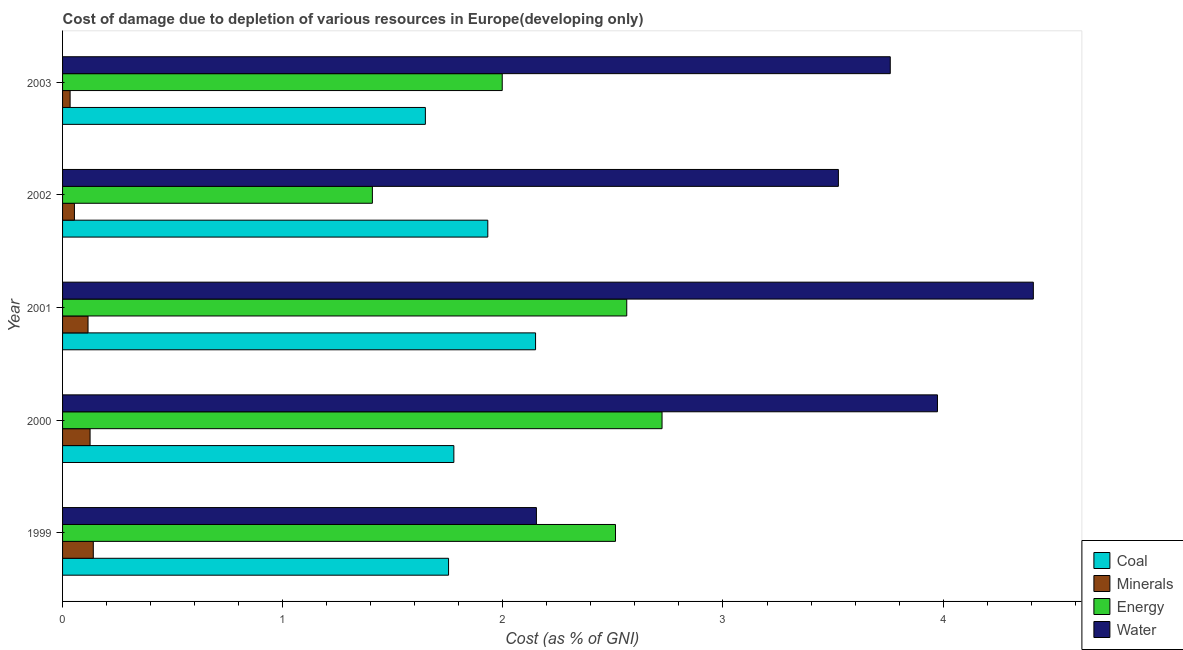Are the number of bars per tick equal to the number of legend labels?
Ensure brevity in your answer.  Yes. Are the number of bars on each tick of the Y-axis equal?
Your answer should be compact. Yes. How many bars are there on the 1st tick from the top?
Your answer should be very brief. 4. How many bars are there on the 3rd tick from the bottom?
Make the answer very short. 4. What is the label of the 2nd group of bars from the top?
Your response must be concise. 2002. In how many cases, is the number of bars for a given year not equal to the number of legend labels?
Offer a terse response. 0. What is the cost of damage due to depletion of water in 2001?
Offer a terse response. 4.41. Across all years, what is the maximum cost of damage due to depletion of minerals?
Offer a terse response. 0.14. Across all years, what is the minimum cost of damage due to depletion of energy?
Provide a succinct answer. 1.41. What is the total cost of damage due to depletion of coal in the graph?
Offer a very short reply. 9.26. What is the difference between the cost of damage due to depletion of water in 2001 and that in 2002?
Provide a succinct answer. 0.89. What is the difference between the cost of damage due to depletion of energy in 2002 and the cost of damage due to depletion of minerals in 1999?
Keep it short and to the point. 1.27. What is the average cost of damage due to depletion of energy per year?
Ensure brevity in your answer.  2.24. In the year 2001, what is the difference between the cost of damage due to depletion of energy and cost of damage due to depletion of coal?
Ensure brevity in your answer.  0.41. What is the ratio of the cost of damage due to depletion of minerals in 2000 to that in 2003?
Provide a succinct answer. 3.65. Is the difference between the cost of damage due to depletion of minerals in 2000 and 2001 greater than the difference between the cost of damage due to depletion of energy in 2000 and 2001?
Provide a succinct answer. No. What is the difference between the highest and the second highest cost of damage due to depletion of coal?
Make the answer very short. 0.22. What is the difference between the highest and the lowest cost of damage due to depletion of energy?
Ensure brevity in your answer.  1.32. Is the sum of the cost of damage due to depletion of energy in 1999 and 2001 greater than the maximum cost of damage due to depletion of water across all years?
Keep it short and to the point. Yes. Is it the case that in every year, the sum of the cost of damage due to depletion of coal and cost of damage due to depletion of energy is greater than the sum of cost of damage due to depletion of water and cost of damage due to depletion of minerals?
Offer a terse response. No. What does the 4th bar from the top in 2002 represents?
Give a very brief answer. Coal. What does the 2nd bar from the bottom in 2001 represents?
Your response must be concise. Minerals. Is it the case that in every year, the sum of the cost of damage due to depletion of coal and cost of damage due to depletion of minerals is greater than the cost of damage due to depletion of energy?
Ensure brevity in your answer.  No. How many bars are there?
Provide a succinct answer. 20. Are all the bars in the graph horizontal?
Make the answer very short. Yes. Does the graph contain grids?
Provide a short and direct response. No. How many legend labels are there?
Make the answer very short. 4. How are the legend labels stacked?
Make the answer very short. Vertical. What is the title of the graph?
Provide a succinct answer. Cost of damage due to depletion of various resources in Europe(developing only) . Does "Salary of employees" appear as one of the legend labels in the graph?
Your answer should be very brief. No. What is the label or title of the X-axis?
Give a very brief answer. Cost (as % of GNI). What is the label or title of the Y-axis?
Your response must be concise. Year. What is the Cost (as % of GNI) of Coal in 1999?
Provide a succinct answer. 1.75. What is the Cost (as % of GNI) in Minerals in 1999?
Your answer should be very brief. 0.14. What is the Cost (as % of GNI) in Energy in 1999?
Make the answer very short. 2.51. What is the Cost (as % of GNI) in Water in 1999?
Provide a succinct answer. 2.15. What is the Cost (as % of GNI) in Coal in 2000?
Provide a succinct answer. 1.78. What is the Cost (as % of GNI) of Minerals in 2000?
Offer a terse response. 0.12. What is the Cost (as % of GNI) in Energy in 2000?
Give a very brief answer. 2.72. What is the Cost (as % of GNI) in Water in 2000?
Your response must be concise. 3.97. What is the Cost (as % of GNI) in Coal in 2001?
Give a very brief answer. 2.15. What is the Cost (as % of GNI) in Minerals in 2001?
Provide a succinct answer. 0.12. What is the Cost (as % of GNI) of Energy in 2001?
Offer a terse response. 2.56. What is the Cost (as % of GNI) in Water in 2001?
Provide a short and direct response. 4.41. What is the Cost (as % of GNI) of Coal in 2002?
Give a very brief answer. 1.93. What is the Cost (as % of GNI) of Minerals in 2002?
Your answer should be very brief. 0.05. What is the Cost (as % of GNI) in Energy in 2002?
Keep it short and to the point. 1.41. What is the Cost (as % of GNI) in Water in 2002?
Your answer should be very brief. 3.52. What is the Cost (as % of GNI) of Coal in 2003?
Offer a very short reply. 1.65. What is the Cost (as % of GNI) of Minerals in 2003?
Offer a very short reply. 0.03. What is the Cost (as % of GNI) in Energy in 2003?
Provide a short and direct response. 2. What is the Cost (as % of GNI) of Water in 2003?
Keep it short and to the point. 3.76. Across all years, what is the maximum Cost (as % of GNI) in Coal?
Your answer should be very brief. 2.15. Across all years, what is the maximum Cost (as % of GNI) in Minerals?
Provide a succinct answer. 0.14. Across all years, what is the maximum Cost (as % of GNI) in Energy?
Give a very brief answer. 2.72. Across all years, what is the maximum Cost (as % of GNI) of Water?
Provide a short and direct response. 4.41. Across all years, what is the minimum Cost (as % of GNI) of Coal?
Your answer should be compact. 1.65. Across all years, what is the minimum Cost (as % of GNI) of Minerals?
Provide a succinct answer. 0.03. Across all years, what is the minimum Cost (as % of GNI) of Energy?
Ensure brevity in your answer.  1.41. Across all years, what is the minimum Cost (as % of GNI) in Water?
Offer a terse response. 2.15. What is the total Cost (as % of GNI) in Coal in the graph?
Offer a very short reply. 9.26. What is the total Cost (as % of GNI) of Minerals in the graph?
Make the answer very short. 0.47. What is the total Cost (as % of GNI) of Energy in the graph?
Keep it short and to the point. 11.2. What is the total Cost (as % of GNI) in Water in the graph?
Make the answer very short. 17.82. What is the difference between the Cost (as % of GNI) in Coal in 1999 and that in 2000?
Offer a very short reply. -0.02. What is the difference between the Cost (as % of GNI) of Minerals in 1999 and that in 2000?
Your response must be concise. 0.01. What is the difference between the Cost (as % of GNI) of Energy in 1999 and that in 2000?
Give a very brief answer. -0.21. What is the difference between the Cost (as % of GNI) in Water in 1999 and that in 2000?
Provide a succinct answer. -1.82. What is the difference between the Cost (as % of GNI) in Coal in 1999 and that in 2001?
Provide a succinct answer. -0.4. What is the difference between the Cost (as % of GNI) of Minerals in 1999 and that in 2001?
Offer a very short reply. 0.02. What is the difference between the Cost (as % of GNI) in Energy in 1999 and that in 2001?
Ensure brevity in your answer.  -0.05. What is the difference between the Cost (as % of GNI) in Water in 1999 and that in 2001?
Offer a terse response. -2.26. What is the difference between the Cost (as % of GNI) of Coal in 1999 and that in 2002?
Your response must be concise. -0.18. What is the difference between the Cost (as % of GNI) of Minerals in 1999 and that in 2002?
Provide a short and direct response. 0.09. What is the difference between the Cost (as % of GNI) of Energy in 1999 and that in 2002?
Give a very brief answer. 1.1. What is the difference between the Cost (as % of GNI) of Water in 1999 and that in 2002?
Offer a very short reply. -1.37. What is the difference between the Cost (as % of GNI) of Coal in 1999 and that in 2003?
Your answer should be very brief. 0.11. What is the difference between the Cost (as % of GNI) of Minerals in 1999 and that in 2003?
Ensure brevity in your answer.  0.11. What is the difference between the Cost (as % of GNI) in Energy in 1999 and that in 2003?
Provide a short and direct response. 0.51. What is the difference between the Cost (as % of GNI) in Water in 1999 and that in 2003?
Give a very brief answer. -1.61. What is the difference between the Cost (as % of GNI) of Coal in 2000 and that in 2001?
Offer a terse response. -0.37. What is the difference between the Cost (as % of GNI) of Minerals in 2000 and that in 2001?
Provide a short and direct response. 0.01. What is the difference between the Cost (as % of GNI) of Energy in 2000 and that in 2001?
Offer a very short reply. 0.16. What is the difference between the Cost (as % of GNI) in Water in 2000 and that in 2001?
Provide a short and direct response. -0.44. What is the difference between the Cost (as % of GNI) in Coal in 2000 and that in 2002?
Ensure brevity in your answer.  -0.15. What is the difference between the Cost (as % of GNI) in Minerals in 2000 and that in 2002?
Give a very brief answer. 0.07. What is the difference between the Cost (as % of GNI) of Energy in 2000 and that in 2002?
Offer a terse response. 1.32. What is the difference between the Cost (as % of GNI) of Water in 2000 and that in 2002?
Keep it short and to the point. 0.45. What is the difference between the Cost (as % of GNI) in Coal in 2000 and that in 2003?
Your answer should be compact. 0.13. What is the difference between the Cost (as % of GNI) of Minerals in 2000 and that in 2003?
Give a very brief answer. 0.09. What is the difference between the Cost (as % of GNI) in Energy in 2000 and that in 2003?
Make the answer very short. 0.73. What is the difference between the Cost (as % of GNI) in Water in 2000 and that in 2003?
Ensure brevity in your answer.  0.21. What is the difference between the Cost (as % of GNI) in Coal in 2001 and that in 2002?
Keep it short and to the point. 0.22. What is the difference between the Cost (as % of GNI) in Minerals in 2001 and that in 2002?
Keep it short and to the point. 0.06. What is the difference between the Cost (as % of GNI) of Energy in 2001 and that in 2002?
Provide a succinct answer. 1.16. What is the difference between the Cost (as % of GNI) in Water in 2001 and that in 2002?
Your response must be concise. 0.89. What is the difference between the Cost (as % of GNI) in Coal in 2001 and that in 2003?
Your answer should be compact. 0.5. What is the difference between the Cost (as % of GNI) of Minerals in 2001 and that in 2003?
Your answer should be very brief. 0.08. What is the difference between the Cost (as % of GNI) of Energy in 2001 and that in 2003?
Provide a succinct answer. 0.57. What is the difference between the Cost (as % of GNI) of Water in 2001 and that in 2003?
Provide a succinct answer. 0.65. What is the difference between the Cost (as % of GNI) in Coal in 2002 and that in 2003?
Give a very brief answer. 0.28. What is the difference between the Cost (as % of GNI) of Minerals in 2002 and that in 2003?
Ensure brevity in your answer.  0.02. What is the difference between the Cost (as % of GNI) of Energy in 2002 and that in 2003?
Offer a terse response. -0.59. What is the difference between the Cost (as % of GNI) in Water in 2002 and that in 2003?
Your answer should be very brief. -0.24. What is the difference between the Cost (as % of GNI) of Coal in 1999 and the Cost (as % of GNI) of Minerals in 2000?
Your response must be concise. 1.63. What is the difference between the Cost (as % of GNI) of Coal in 1999 and the Cost (as % of GNI) of Energy in 2000?
Provide a short and direct response. -0.97. What is the difference between the Cost (as % of GNI) in Coal in 1999 and the Cost (as % of GNI) in Water in 2000?
Your answer should be very brief. -2.22. What is the difference between the Cost (as % of GNI) in Minerals in 1999 and the Cost (as % of GNI) in Energy in 2000?
Keep it short and to the point. -2.58. What is the difference between the Cost (as % of GNI) of Minerals in 1999 and the Cost (as % of GNI) of Water in 2000?
Your answer should be compact. -3.83. What is the difference between the Cost (as % of GNI) in Energy in 1999 and the Cost (as % of GNI) in Water in 2000?
Give a very brief answer. -1.46. What is the difference between the Cost (as % of GNI) in Coal in 1999 and the Cost (as % of GNI) in Minerals in 2001?
Your answer should be compact. 1.64. What is the difference between the Cost (as % of GNI) in Coal in 1999 and the Cost (as % of GNI) in Energy in 2001?
Keep it short and to the point. -0.81. What is the difference between the Cost (as % of GNI) in Coal in 1999 and the Cost (as % of GNI) in Water in 2001?
Ensure brevity in your answer.  -2.66. What is the difference between the Cost (as % of GNI) of Minerals in 1999 and the Cost (as % of GNI) of Energy in 2001?
Provide a succinct answer. -2.42. What is the difference between the Cost (as % of GNI) in Minerals in 1999 and the Cost (as % of GNI) in Water in 2001?
Provide a short and direct response. -4.27. What is the difference between the Cost (as % of GNI) in Energy in 1999 and the Cost (as % of GNI) in Water in 2001?
Provide a succinct answer. -1.9. What is the difference between the Cost (as % of GNI) in Coal in 1999 and the Cost (as % of GNI) in Minerals in 2002?
Your answer should be compact. 1.7. What is the difference between the Cost (as % of GNI) of Coal in 1999 and the Cost (as % of GNI) of Energy in 2002?
Give a very brief answer. 0.35. What is the difference between the Cost (as % of GNI) in Coal in 1999 and the Cost (as % of GNI) in Water in 2002?
Your answer should be compact. -1.77. What is the difference between the Cost (as % of GNI) in Minerals in 1999 and the Cost (as % of GNI) in Energy in 2002?
Offer a terse response. -1.27. What is the difference between the Cost (as % of GNI) in Minerals in 1999 and the Cost (as % of GNI) in Water in 2002?
Keep it short and to the point. -3.38. What is the difference between the Cost (as % of GNI) of Energy in 1999 and the Cost (as % of GNI) of Water in 2002?
Your response must be concise. -1.01. What is the difference between the Cost (as % of GNI) in Coal in 1999 and the Cost (as % of GNI) in Minerals in 2003?
Make the answer very short. 1.72. What is the difference between the Cost (as % of GNI) of Coal in 1999 and the Cost (as % of GNI) of Energy in 2003?
Your answer should be compact. -0.24. What is the difference between the Cost (as % of GNI) of Coal in 1999 and the Cost (as % of GNI) of Water in 2003?
Provide a succinct answer. -2.01. What is the difference between the Cost (as % of GNI) in Minerals in 1999 and the Cost (as % of GNI) in Energy in 2003?
Your answer should be compact. -1.86. What is the difference between the Cost (as % of GNI) in Minerals in 1999 and the Cost (as % of GNI) in Water in 2003?
Offer a very short reply. -3.62. What is the difference between the Cost (as % of GNI) of Energy in 1999 and the Cost (as % of GNI) of Water in 2003?
Ensure brevity in your answer.  -1.25. What is the difference between the Cost (as % of GNI) in Coal in 2000 and the Cost (as % of GNI) in Minerals in 2001?
Provide a succinct answer. 1.66. What is the difference between the Cost (as % of GNI) of Coal in 2000 and the Cost (as % of GNI) of Energy in 2001?
Offer a very short reply. -0.79. What is the difference between the Cost (as % of GNI) in Coal in 2000 and the Cost (as % of GNI) in Water in 2001?
Make the answer very short. -2.63. What is the difference between the Cost (as % of GNI) of Minerals in 2000 and the Cost (as % of GNI) of Energy in 2001?
Provide a short and direct response. -2.44. What is the difference between the Cost (as % of GNI) of Minerals in 2000 and the Cost (as % of GNI) of Water in 2001?
Give a very brief answer. -4.28. What is the difference between the Cost (as % of GNI) of Energy in 2000 and the Cost (as % of GNI) of Water in 2001?
Offer a terse response. -1.69. What is the difference between the Cost (as % of GNI) of Coal in 2000 and the Cost (as % of GNI) of Minerals in 2002?
Ensure brevity in your answer.  1.72. What is the difference between the Cost (as % of GNI) of Coal in 2000 and the Cost (as % of GNI) of Energy in 2002?
Keep it short and to the point. 0.37. What is the difference between the Cost (as % of GNI) of Coal in 2000 and the Cost (as % of GNI) of Water in 2002?
Offer a terse response. -1.75. What is the difference between the Cost (as % of GNI) in Minerals in 2000 and the Cost (as % of GNI) in Energy in 2002?
Give a very brief answer. -1.28. What is the difference between the Cost (as % of GNI) of Minerals in 2000 and the Cost (as % of GNI) of Water in 2002?
Offer a very short reply. -3.4. What is the difference between the Cost (as % of GNI) of Energy in 2000 and the Cost (as % of GNI) of Water in 2002?
Your answer should be compact. -0.8. What is the difference between the Cost (as % of GNI) in Coal in 2000 and the Cost (as % of GNI) in Minerals in 2003?
Offer a terse response. 1.74. What is the difference between the Cost (as % of GNI) of Coal in 2000 and the Cost (as % of GNI) of Energy in 2003?
Ensure brevity in your answer.  -0.22. What is the difference between the Cost (as % of GNI) of Coal in 2000 and the Cost (as % of GNI) of Water in 2003?
Make the answer very short. -1.98. What is the difference between the Cost (as % of GNI) in Minerals in 2000 and the Cost (as % of GNI) in Energy in 2003?
Make the answer very short. -1.87. What is the difference between the Cost (as % of GNI) of Minerals in 2000 and the Cost (as % of GNI) of Water in 2003?
Offer a very short reply. -3.63. What is the difference between the Cost (as % of GNI) in Energy in 2000 and the Cost (as % of GNI) in Water in 2003?
Your answer should be very brief. -1.04. What is the difference between the Cost (as % of GNI) in Coal in 2001 and the Cost (as % of GNI) in Minerals in 2002?
Your response must be concise. 2.09. What is the difference between the Cost (as % of GNI) in Coal in 2001 and the Cost (as % of GNI) in Energy in 2002?
Provide a succinct answer. 0.74. What is the difference between the Cost (as % of GNI) of Coal in 2001 and the Cost (as % of GNI) of Water in 2002?
Ensure brevity in your answer.  -1.38. What is the difference between the Cost (as % of GNI) of Minerals in 2001 and the Cost (as % of GNI) of Energy in 2002?
Offer a terse response. -1.29. What is the difference between the Cost (as % of GNI) of Minerals in 2001 and the Cost (as % of GNI) of Water in 2002?
Your response must be concise. -3.41. What is the difference between the Cost (as % of GNI) of Energy in 2001 and the Cost (as % of GNI) of Water in 2002?
Offer a very short reply. -0.96. What is the difference between the Cost (as % of GNI) of Coal in 2001 and the Cost (as % of GNI) of Minerals in 2003?
Ensure brevity in your answer.  2.11. What is the difference between the Cost (as % of GNI) of Coal in 2001 and the Cost (as % of GNI) of Energy in 2003?
Make the answer very short. 0.15. What is the difference between the Cost (as % of GNI) of Coal in 2001 and the Cost (as % of GNI) of Water in 2003?
Keep it short and to the point. -1.61. What is the difference between the Cost (as % of GNI) of Minerals in 2001 and the Cost (as % of GNI) of Energy in 2003?
Provide a succinct answer. -1.88. What is the difference between the Cost (as % of GNI) in Minerals in 2001 and the Cost (as % of GNI) in Water in 2003?
Offer a very short reply. -3.64. What is the difference between the Cost (as % of GNI) of Energy in 2001 and the Cost (as % of GNI) of Water in 2003?
Your answer should be very brief. -1.2. What is the difference between the Cost (as % of GNI) in Coal in 2002 and the Cost (as % of GNI) in Minerals in 2003?
Your answer should be very brief. 1.9. What is the difference between the Cost (as % of GNI) in Coal in 2002 and the Cost (as % of GNI) in Energy in 2003?
Your answer should be compact. -0.07. What is the difference between the Cost (as % of GNI) in Coal in 2002 and the Cost (as % of GNI) in Water in 2003?
Your answer should be very brief. -1.83. What is the difference between the Cost (as % of GNI) of Minerals in 2002 and the Cost (as % of GNI) of Energy in 2003?
Your response must be concise. -1.94. What is the difference between the Cost (as % of GNI) in Minerals in 2002 and the Cost (as % of GNI) in Water in 2003?
Give a very brief answer. -3.71. What is the difference between the Cost (as % of GNI) in Energy in 2002 and the Cost (as % of GNI) in Water in 2003?
Offer a terse response. -2.35. What is the average Cost (as % of GNI) of Coal per year?
Provide a short and direct response. 1.85. What is the average Cost (as % of GNI) of Minerals per year?
Make the answer very short. 0.09. What is the average Cost (as % of GNI) of Energy per year?
Give a very brief answer. 2.24. What is the average Cost (as % of GNI) of Water per year?
Provide a short and direct response. 3.56. In the year 1999, what is the difference between the Cost (as % of GNI) in Coal and Cost (as % of GNI) in Minerals?
Your answer should be very brief. 1.61. In the year 1999, what is the difference between the Cost (as % of GNI) in Coal and Cost (as % of GNI) in Energy?
Your answer should be compact. -0.76. In the year 1999, what is the difference between the Cost (as % of GNI) in Coal and Cost (as % of GNI) in Water?
Make the answer very short. -0.4. In the year 1999, what is the difference between the Cost (as % of GNI) of Minerals and Cost (as % of GNI) of Energy?
Make the answer very short. -2.37. In the year 1999, what is the difference between the Cost (as % of GNI) in Minerals and Cost (as % of GNI) in Water?
Keep it short and to the point. -2.01. In the year 1999, what is the difference between the Cost (as % of GNI) of Energy and Cost (as % of GNI) of Water?
Give a very brief answer. 0.36. In the year 2000, what is the difference between the Cost (as % of GNI) of Coal and Cost (as % of GNI) of Minerals?
Offer a very short reply. 1.65. In the year 2000, what is the difference between the Cost (as % of GNI) of Coal and Cost (as % of GNI) of Energy?
Ensure brevity in your answer.  -0.95. In the year 2000, what is the difference between the Cost (as % of GNI) of Coal and Cost (as % of GNI) of Water?
Ensure brevity in your answer.  -2.2. In the year 2000, what is the difference between the Cost (as % of GNI) of Minerals and Cost (as % of GNI) of Energy?
Ensure brevity in your answer.  -2.6. In the year 2000, what is the difference between the Cost (as % of GNI) of Minerals and Cost (as % of GNI) of Water?
Give a very brief answer. -3.85. In the year 2000, what is the difference between the Cost (as % of GNI) of Energy and Cost (as % of GNI) of Water?
Ensure brevity in your answer.  -1.25. In the year 2001, what is the difference between the Cost (as % of GNI) of Coal and Cost (as % of GNI) of Minerals?
Ensure brevity in your answer.  2.03. In the year 2001, what is the difference between the Cost (as % of GNI) of Coal and Cost (as % of GNI) of Energy?
Keep it short and to the point. -0.41. In the year 2001, what is the difference between the Cost (as % of GNI) of Coal and Cost (as % of GNI) of Water?
Offer a terse response. -2.26. In the year 2001, what is the difference between the Cost (as % of GNI) of Minerals and Cost (as % of GNI) of Energy?
Provide a succinct answer. -2.45. In the year 2001, what is the difference between the Cost (as % of GNI) of Minerals and Cost (as % of GNI) of Water?
Provide a short and direct response. -4.29. In the year 2001, what is the difference between the Cost (as % of GNI) in Energy and Cost (as % of GNI) in Water?
Make the answer very short. -1.85. In the year 2002, what is the difference between the Cost (as % of GNI) in Coal and Cost (as % of GNI) in Minerals?
Give a very brief answer. 1.88. In the year 2002, what is the difference between the Cost (as % of GNI) in Coal and Cost (as % of GNI) in Energy?
Offer a terse response. 0.52. In the year 2002, what is the difference between the Cost (as % of GNI) in Coal and Cost (as % of GNI) in Water?
Make the answer very short. -1.59. In the year 2002, what is the difference between the Cost (as % of GNI) in Minerals and Cost (as % of GNI) in Energy?
Your answer should be very brief. -1.35. In the year 2002, what is the difference between the Cost (as % of GNI) in Minerals and Cost (as % of GNI) in Water?
Make the answer very short. -3.47. In the year 2002, what is the difference between the Cost (as % of GNI) in Energy and Cost (as % of GNI) in Water?
Your response must be concise. -2.12. In the year 2003, what is the difference between the Cost (as % of GNI) of Coal and Cost (as % of GNI) of Minerals?
Your response must be concise. 1.61. In the year 2003, what is the difference between the Cost (as % of GNI) in Coal and Cost (as % of GNI) in Energy?
Your answer should be very brief. -0.35. In the year 2003, what is the difference between the Cost (as % of GNI) of Coal and Cost (as % of GNI) of Water?
Your response must be concise. -2.11. In the year 2003, what is the difference between the Cost (as % of GNI) in Minerals and Cost (as % of GNI) in Energy?
Keep it short and to the point. -1.96. In the year 2003, what is the difference between the Cost (as % of GNI) of Minerals and Cost (as % of GNI) of Water?
Provide a succinct answer. -3.73. In the year 2003, what is the difference between the Cost (as % of GNI) of Energy and Cost (as % of GNI) of Water?
Make the answer very short. -1.76. What is the ratio of the Cost (as % of GNI) in Coal in 1999 to that in 2000?
Make the answer very short. 0.99. What is the ratio of the Cost (as % of GNI) in Minerals in 1999 to that in 2000?
Your response must be concise. 1.12. What is the ratio of the Cost (as % of GNI) of Energy in 1999 to that in 2000?
Offer a very short reply. 0.92. What is the ratio of the Cost (as % of GNI) of Water in 1999 to that in 2000?
Your answer should be very brief. 0.54. What is the ratio of the Cost (as % of GNI) of Coal in 1999 to that in 2001?
Your answer should be compact. 0.82. What is the ratio of the Cost (as % of GNI) in Minerals in 1999 to that in 2001?
Ensure brevity in your answer.  1.21. What is the ratio of the Cost (as % of GNI) of Water in 1999 to that in 2001?
Offer a very short reply. 0.49. What is the ratio of the Cost (as % of GNI) in Coal in 1999 to that in 2002?
Offer a very short reply. 0.91. What is the ratio of the Cost (as % of GNI) in Minerals in 1999 to that in 2002?
Your answer should be compact. 2.59. What is the ratio of the Cost (as % of GNI) of Energy in 1999 to that in 2002?
Offer a very short reply. 1.78. What is the ratio of the Cost (as % of GNI) in Water in 1999 to that in 2002?
Your response must be concise. 0.61. What is the ratio of the Cost (as % of GNI) of Coal in 1999 to that in 2003?
Offer a very short reply. 1.06. What is the ratio of the Cost (as % of GNI) of Minerals in 1999 to that in 2003?
Provide a short and direct response. 4.07. What is the ratio of the Cost (as % of GNI) in Energy in 1999 to that in 2003?
Your answer should be compact. 1.26. What is the ratio of the Cost (as % of GNI) of Water in 1999 to that in 2003?
Give a very brief answer. 0.57. What is the ratio of the Cost (as % of GNI) in Coal in 2000 to that in 2001?
Make the answer very short. 0.83. What is the ratio of the Cost (as % of GNI) of Minerals in 2000 to that in 2001?
Your response must be concise. 1.08. What is the ratio of the Cost (as % of GNI) in Energy in 2000 to that in 2001?
Make the answer very short. 1.06. What is the ratio of the Cost (as % of GNI) in Water in 2000 to that in 2001?
Provide a succinct answer. 0.9. What is the ratio of the Cost (as % of GNI) in Coal in 2000 to that in 2002?
Your answer should be compact. 0.92. What is the ratio of the Cost (as % of GNI) of Minerals in 2000 to that in 2002?
Offer a terse response. 2.32. What is the ratio of the Cost (as % of GNI) in Energy in 2000 to that in 2002?
Your response must be concise. 1.93. What is the ratio of the Cost (as % of GNI) in Water in 2000 to that in 2002?
Your answer should be compact. 1.13. What is the ratio of the Cost (as % of GNI) in Coal in 2000 to that in 2003?
Your response must be concise. 1.08. What is the ratio of the Cost (as % of GNI) in Minerals in 2000 to that in 2003?
Offer a terse response. 3.64. What is the ratio of the Cost (as % of GNI) of Energy in 2000 to that in 2003?
Keep it short and to the point. 1.36. What is the ratio of the Cost (as % of GNI) of Water in 2000 to that in 2003?
Keep it short and to the point. 1.06. What is the ratio of the Cost (as % of GNI) of Coal in 2001 to that in 2002?
Make the answer very short. 1.11. What is the ratio of the Cost (as % of GNI) of Minerals in 2001 to that in 2002?
Your answer should be very brief. 2.15. What is the ratio of the Cost (as % of GNI) of Energy in 2001 to that in 2002?
Give a very brief answer. 1.82. What is the ratio of the Cost (as % of GNI) in Water in 2001 to that in 2002?
Provide a succinct answer. 1.25. What is the ratio of the Cost (as % of GNI) of Coal in 2001 to that in 2003?
Your answer should be compact. 1.3. What is the ratio of the Cost (as % of GNI) of Minerals in 2001 to that in 2003?
Ensure brevity in your answer.  3.37. What is the ratio of the Cost (as % of GNI) in Energy in 2001 to that in 2003?
Ensure brevity in your answer.  1.28. What is the ratio of the Cost (as % of GNI) of Water in 2001 to that in 2003?
Your response must be concise. 1.17. What is the ratio of the Cost (as % of GNI) in Coal in 2002 to that in 2003?
Provide a short and direct response. 1.17. What is the ratio of the Cost (as % of GNI) in Minerals in 2002 to that in 2003?
Ensure brevity in your answer.  1.57. What is the ratio of the Cost (as % of GNI) of Energy in 2002 to that in 2003?
Your answer should be compact. 0.7. What is the ratio of the Cost (as % of GNI) of Water in 2002 to that in 2003?
Provide a short and direct response. 0.94. What is the difference between the highest and the second highest Cost (as % of GNI) in Coal?
Provide a succinct answer. 0.22. What is the difference between the highest and the second highest Cost (as % of GNI) of Minerals?
Keep it short and to the point. 0.01. What is the difference between the highest and the second highest Cost (as % of GNI) in Energy?
Make the answer very short. 0.16. What is the difference between the highest and the second highest Cost (as % of GNI) in Water?
Give a very brief answer. 0.44. What is the difference between the highest and the lowest Cost (as % of GNI) of Coal?
Offer a terse response. 0.5. What is the difference between the highest and the lowest Cost (as % of GNI) in Minerals?
Provide a short and direct response. 0.11. What is the difference between the highest and the lowest Cost (as % of GNI) in Energy?
Your answer should be very brief. 1.32. What is the difference between the highest and the lowest Cost (as % of GNI) of Water?
Make the answer very short. 2.26. 